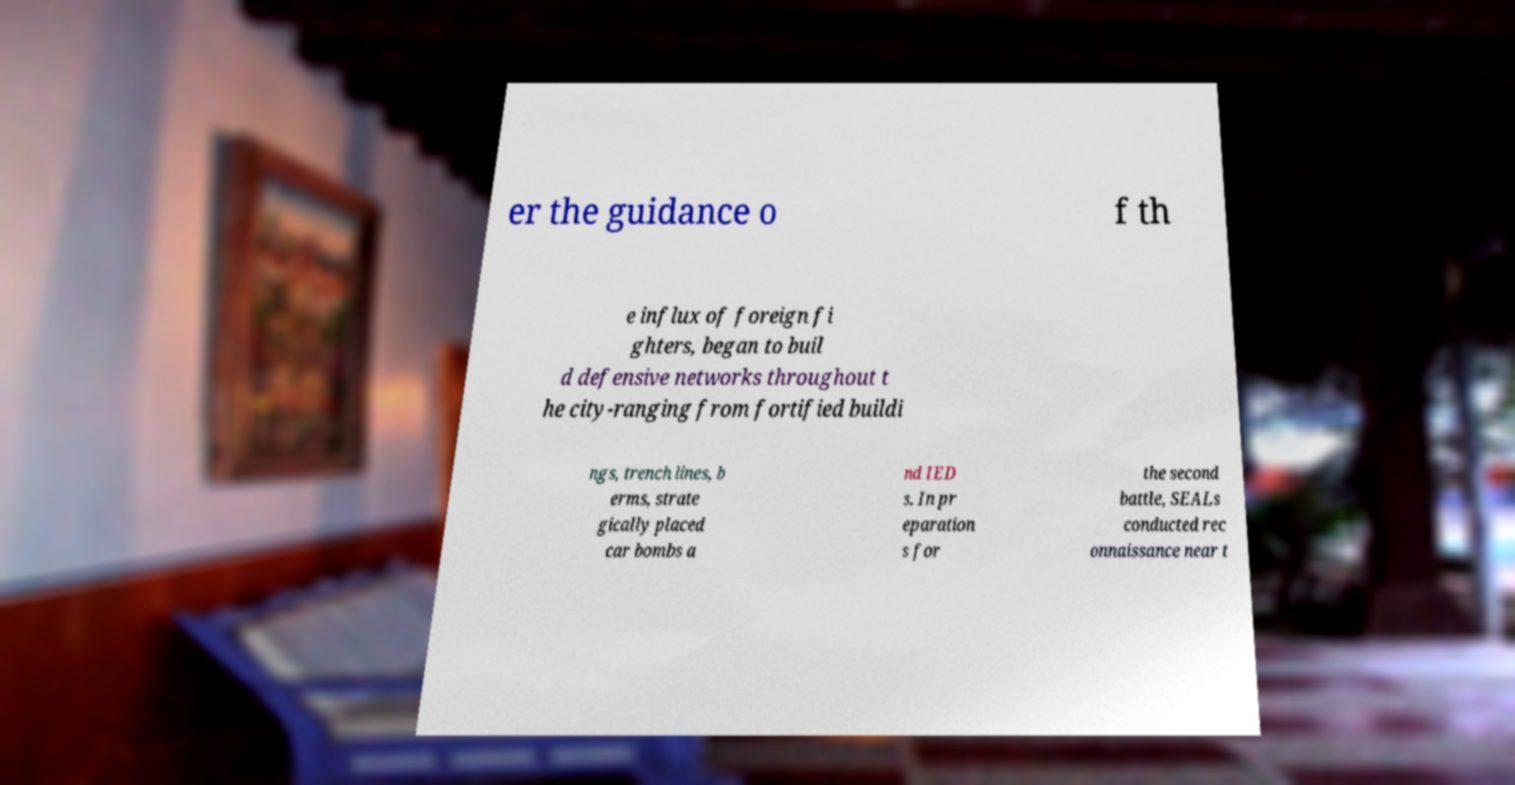Please identify and transcribe the text found in this image. er the guidance o f th e influx of foreign fi ghters, began to buil d defensive networks throughout t he city-ranging from fortified buildi ngs, trench lines, b erms, strate gically placed car bombs a nd IED s. In pr eparation s for the second battle, SEALs conducted rec onnaissance near t 